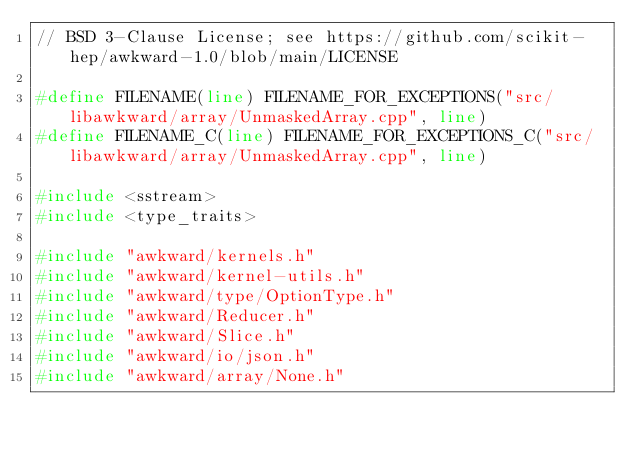Convert code to text. <code><loc_0><loc_0><loc_500><loc_500><_C++_>// BSD 3-Clause License; see https://github.com/scikit-hep/awkward-1.0/blob/main/LICENSE

#define FILENAME(line) FILENAME_FOR_EXCEPTIONS("src/libawkward/array/UnmaskedArray.cpp", line)
#define FILENAME_C(line) FILENAME_FOR_EXCEPTIONS_C("src/libawkward/array/UnmaskedArray.cpp", line)

#include <sstream>
#include <type_traits>

#include "awkward/kernels.h"
#include "awkward/kernel-utils.h"
#include "awkward/type/OptionType.h"
#include "awkward/Reducer.h"
#include "awkward/Slice.h"
#include "awkward/io/json.h"
#include "awkward/array/None.h"</code> 